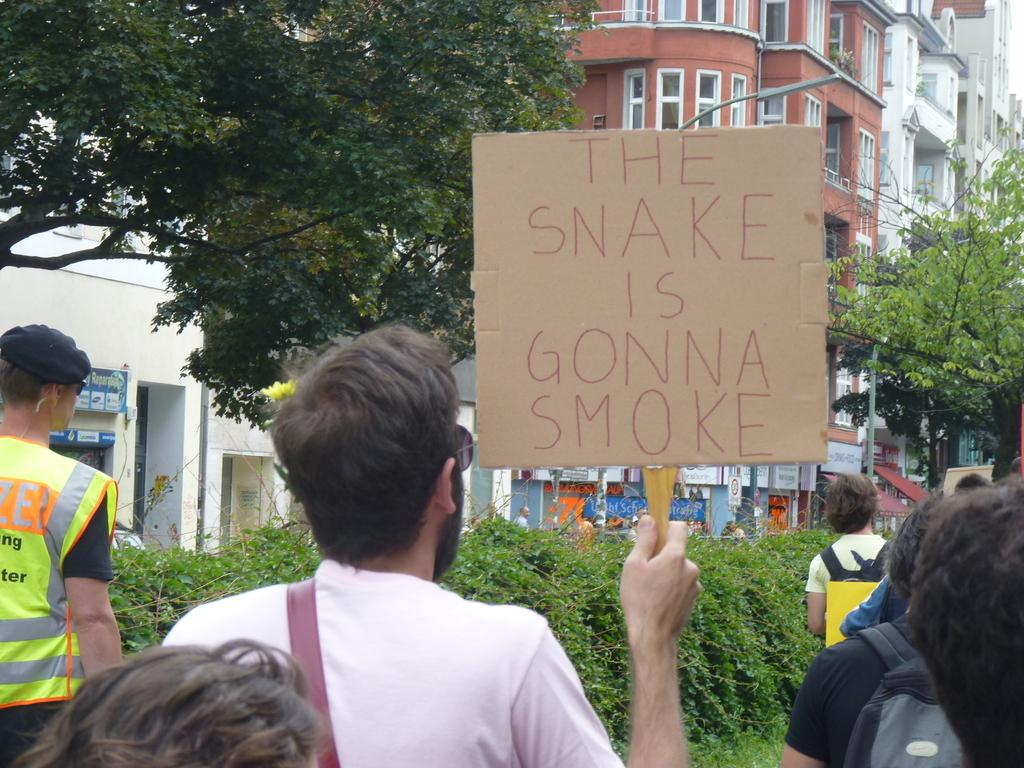How many persons can be seen in the image? There are persons in the image, but the exact number is not specified. What is one person holding in the image? One person is holding a board with a stick in the image. What type of natural elements are present in the image? There are plants and trees in the image. What can be seen in the background of the image? Buildings, trees, a light on a pole, and windows are visible in the background of the image. What songs are being sung by the persons in the image? There is no information about any songs being sung in the image. How does the window in the image smash into pieces? There is no window present in the image that can be smashed into pieces. 